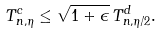<formula> <loc_0><loc_0><loc_500><loc_500>T ^ { c } _ { n , \eta } \leq \sqrt { 1 + \epsilon } \, T ^ { d } _ { n , \eta / 2 } .</formula> 